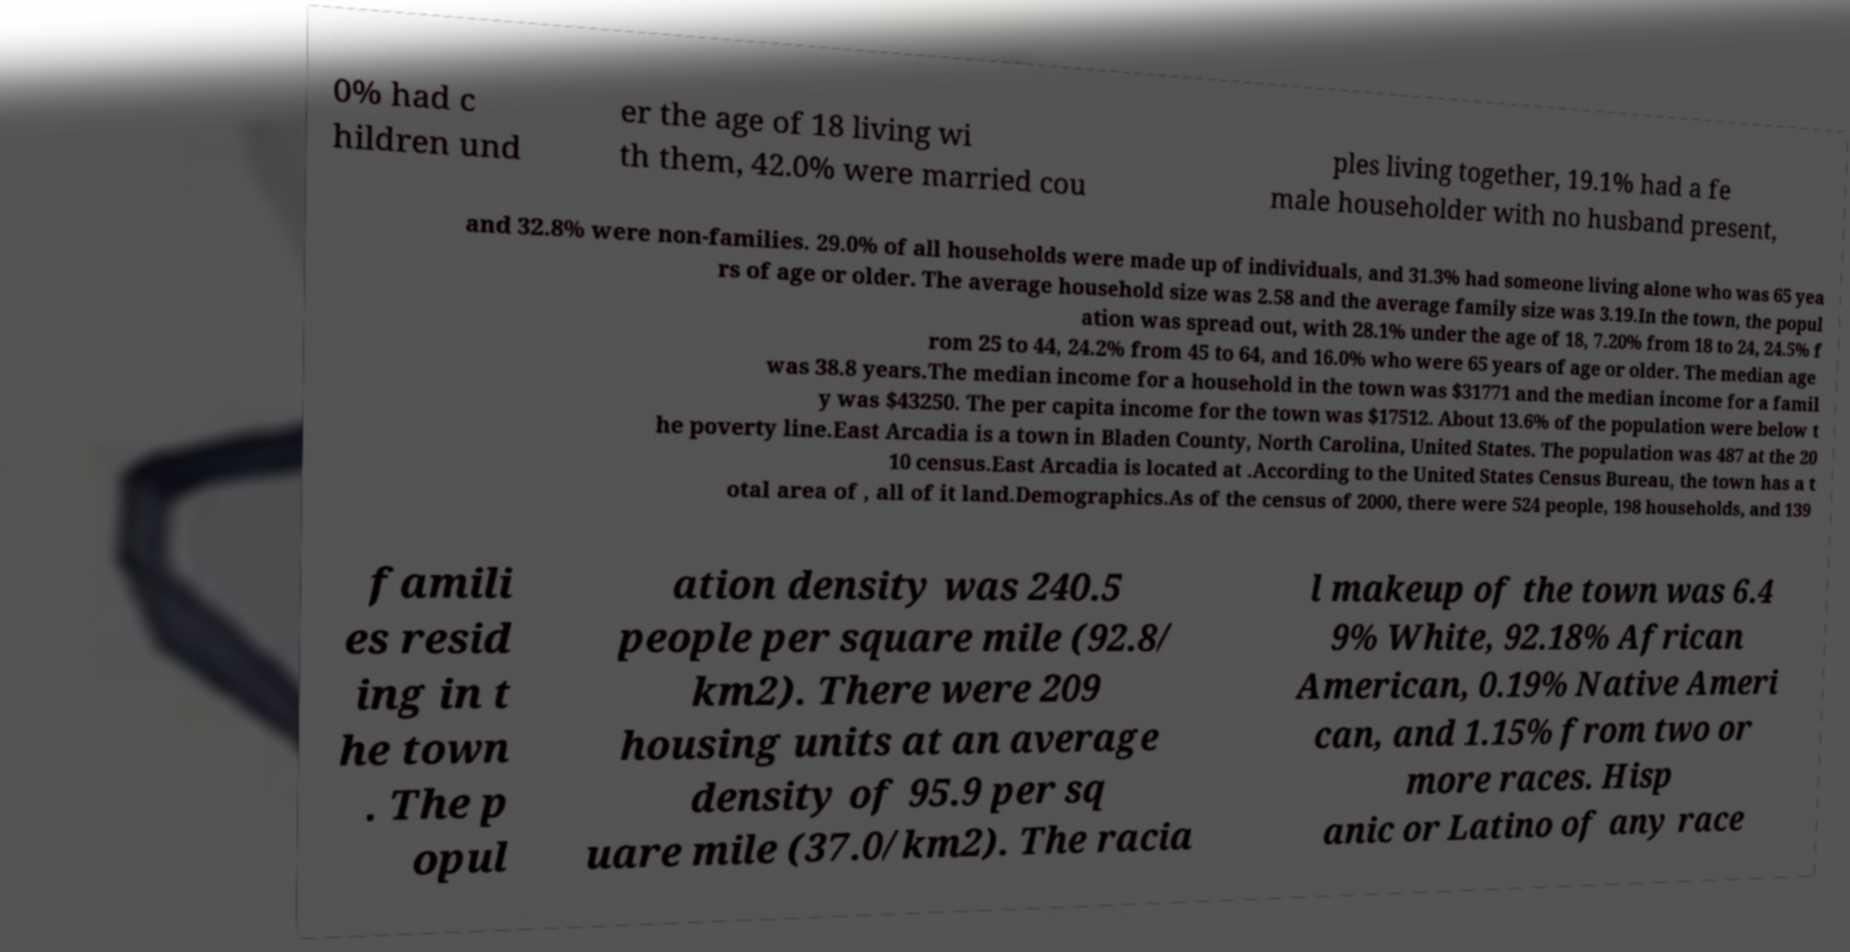Can you read and provide the text displayed in the image?This photo seems to have some interesting text. Can you extract and type it out for me? 0% had c hildren und er the age of 18 living wi th them, 42.0% were married cou ples living together, 19.1% had a fe male householder with no husband present, and 32.8% were non-families. 29.0% of all households were made up of individuals, and 31.3% had someone living alone who was 65 yea rs of age or older. The average household size was 2.58 and the average family size was 3.19.In the town, the popul ation was spread out, with 28.1% under the age of 18, 7.20% from 18 to 24, 24.5% f rom 25 to 44, 24.2% from 45 to 64, and 16.0% who were 65 years of age or older. The median age was 38.8 years.The median income for a household in the town was $31771 and the median income for a famil y was $43250. The per capita income for the town was $17512. About 13.6% of the population were below t he poverty line.East Arcadia is a town in Bladen County, North Carolina, United States. The population was 487 at the 20 10 census.East Arcadia is located at .According to the United States Census Bureau, the town has a t otal area of , all of it land.Demographics.As of the census of 2000, there were 524 people, 198 households, and 139 famili es resid ing in t he town . The p opul ation density was 240.5 people per square mile (92.8/ km2). There were 209 housing units at an average density of 95.9 per sq uare mile (37.0/km2). The racia l makeup of the town was 6.4 9% White, 92.18% African American, 0.19% Native Ameri can, and 1.15% from two or more races. Hisp anic or Latino of any race 